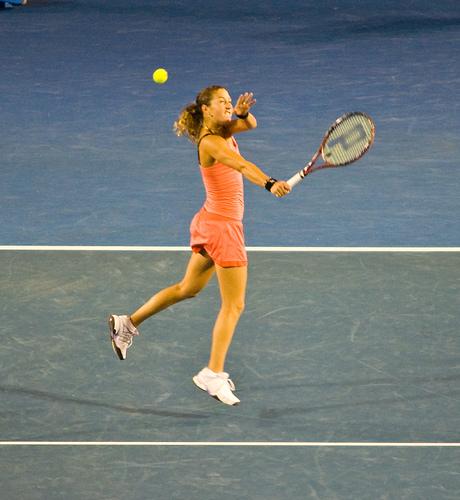What letter is on the racket?
Concise answer only. P. What color are her shoes?
Keep it brief. White. What color is the ball?
Answer briefly. Yellow. 